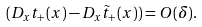<formula> <loc_0><loc_0><loc_500><loc_500>( D _ { x } t _ { + } ( x ) - D _ { x } \tilde { t } _ { + } ( x ) ) = O ( \delta ) .</formula> 